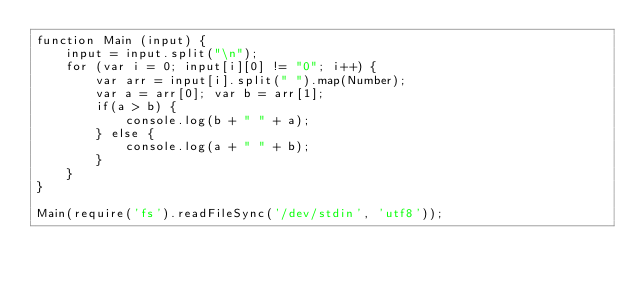<code> <loc_0><loc_0><loc_500><loc_500><_JavaScript_>function Main (input) {
    input = input.split("\n");
    for (var i = 0; input[i][0] != "0"; i++) {
        var arr = input[i].split(" ").map(Number);
        var a = arr[0]; var b = arr[1];
        if(a > b) {
            console.log(b + " " + a);
        } else {
            console.log(a + " " + b);
        }
    }
}

Main(require('fs').readFileSync('/dev/stdin', 'utf8'));</code> 